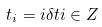<formula> <loc_0><loc_0><loc_500><loc_500>t _ { i } = i \delta t i \in Z</formula> 